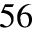Convert formula to latex. <formula><loc_0><loc_0><loc_500><loc_500>^ { 5 6 }</formula> 